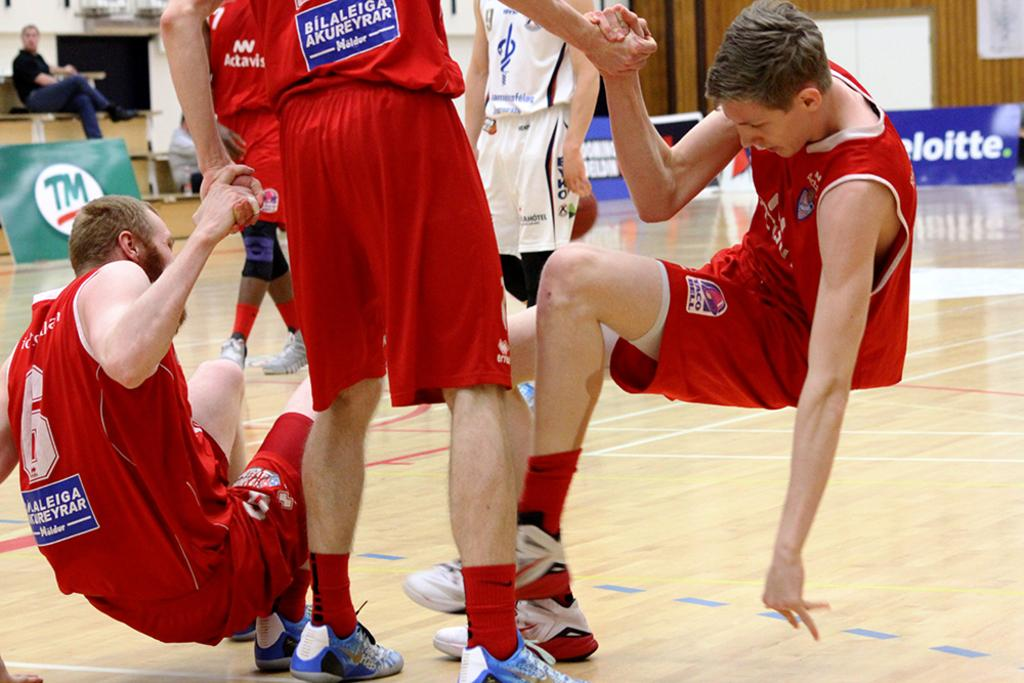<image>
Offer a succinct explanation of the picture presented. A young man in basketball uniform helping two teammates up from the ground at a basketball game sponsored by Deloitte 